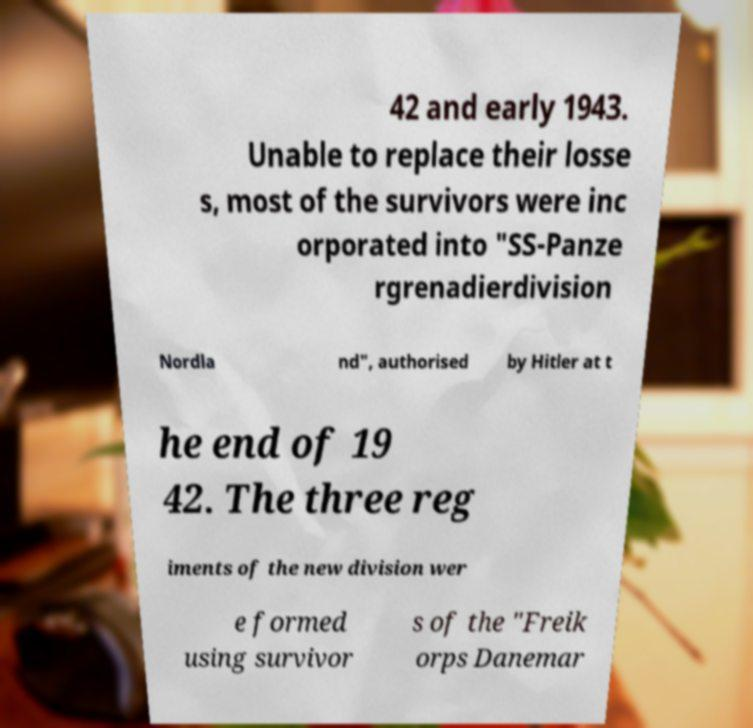For documentation purposes, I need the text within this image transcribed. Could you provide that? 42 and early 1943. Unable to replace their losse s, most of the survivors were inc orporated into "SS-Panze rgrenadierdivision Nordla nd", authorised by Hitler at t he end of 19 42. The three reg iments of the new division wer e formed using survivor s of the "Freik orps Danemar 